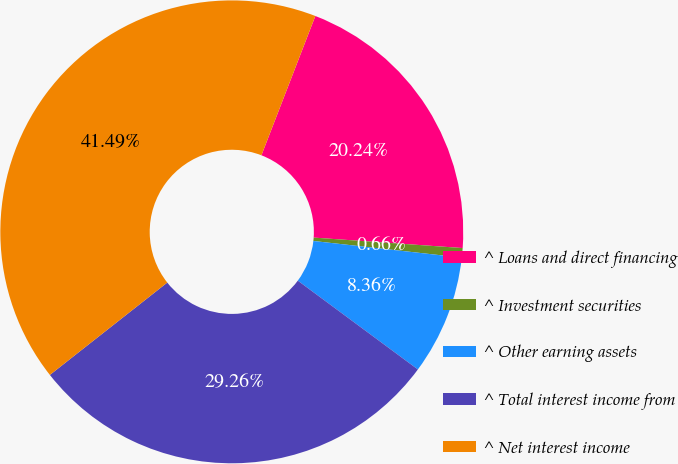Convert chart. <chart><loc_0><loc_0><loc_500><loc_500><pie_chart><fcel>^ Loans and direct financing<fcel>^ Investment securities<fcel>^ Other earning assets<fcel>^ Total interest income from<fcel>^ Net interest income<nl><fcel>20.24%<fcel>0.66%<fcel>8.36%<fcel>29.26%<fcel>41.49%<nl></chart> 